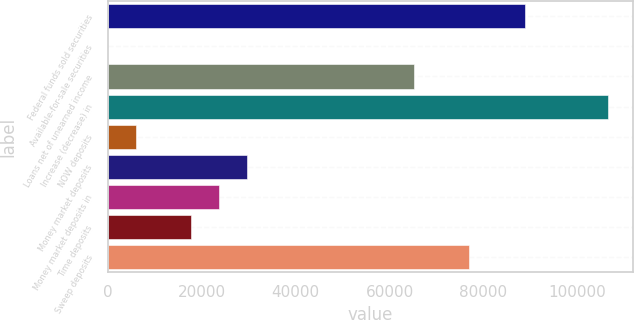<chart> <loc_0><loc_0><loc_500><loc_500><bar_chart><fcel>Federal funds sold securities<fcel>Available-for-sale securities<fcel>Loans net of unearned income<fcel>Increase (decrease) in<fcel>NOW deposits<fcel>Money market deposits<fcel>Money market deposits in<fcel>Time deposits<fcel>Sweep deposits<nl><fcel>88842<fcel>12<fcel>65154<fcel>106608<fcel>5934<fcel>29622<fcel>23700<fcel>17778<fcel>76998<nl></chart> 